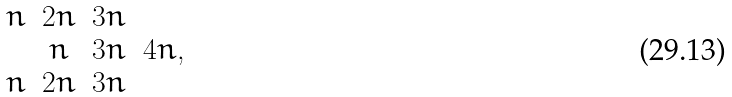<formula> <loc_0><loc_0><loc_500><loc_500>\begin{matrix} n & 2 n & 3 n & \\ & n & 3 n & 4 n , \\ n & 2 n & 3 n & \end{matrix}</formula> 